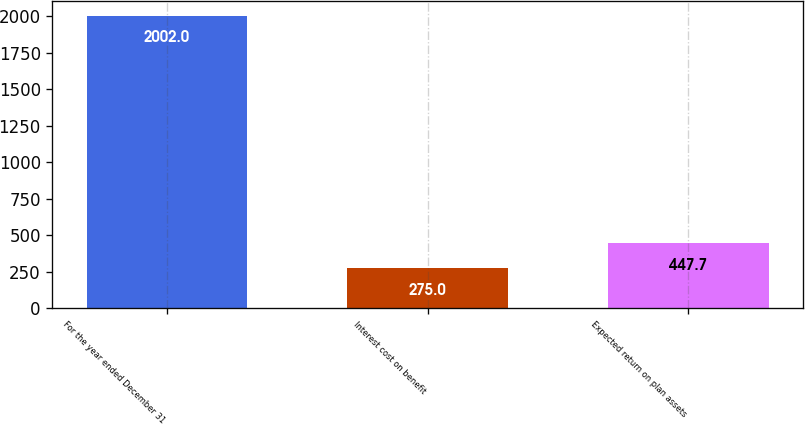Convert chart to OTSL. <chart><loc_0><loc_0><loc_500><loc_500><bar_chart><fcel>For the year ended December 31<fcel>Interest cost on benefit<fcel>Expected return on plan assets<nl><fcel>2002<fcel>275<fcel>447.7<nl></chart> 